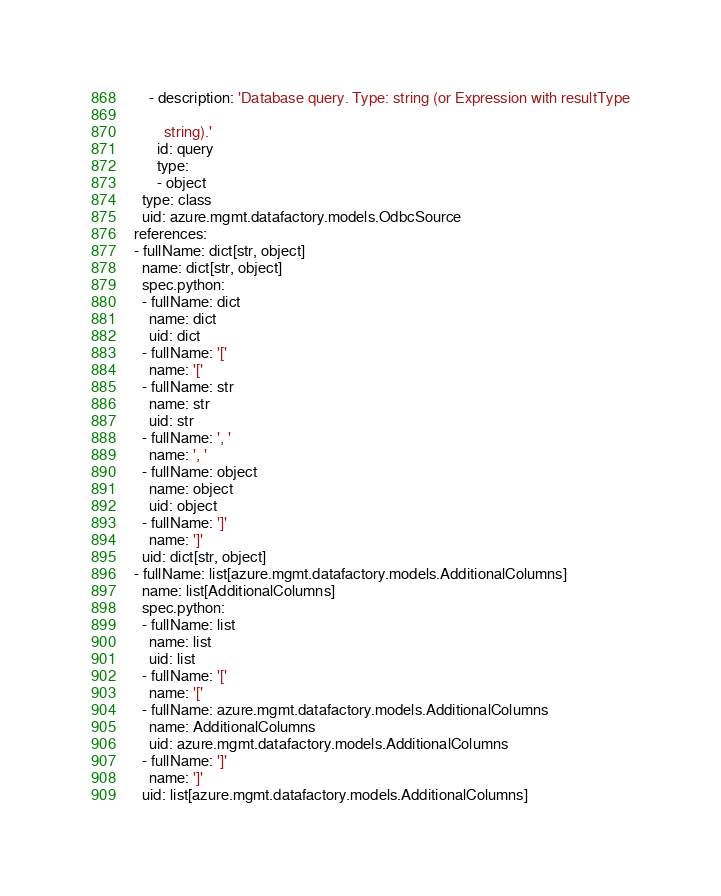<code> <loc_0><loc_0><loc_500><loc_500><_YAML_>    - description: 'Database query. Type: string (or Expression with resultType

        string).'
      id: query
      type:
      - object
  type: class
  uid: azure.mgmt.datafactory.models.OdbcSource
references:
- fullName: dict[str, object]
  name: dict[str, object]
  spec.python:
  - fullName: dict
    name: dict
    uid: dict
  - fullName: '['
    name: '['
  - fullName: str
    name: str
    uid: str
  - fullName: ', '
    name: ', '
  - fullName: object
    name: object
    uid: object
  - fullName: ']'
    name: ']'
  uid: dict[str, object]
- fullName: list[azure.mgmt.datafactory.models.AdditionalColumns]
  name: list[AdditionalColumns]
  spec.python:
  - fullName: list
    name: list
    uid: list
  - fullName: '['
    name: '['
  - fullName: azure.mgmt.datafactory.models.AdditionalColumns
    name: AdditionalColumns
    uid: azure.mgmt.datafactory.models.AdditionalColumns
  - fullName: ']'
    name: ']'
  uid: list[azure.mgmt.datafactory.models.AdditionalColumns]
</code> 